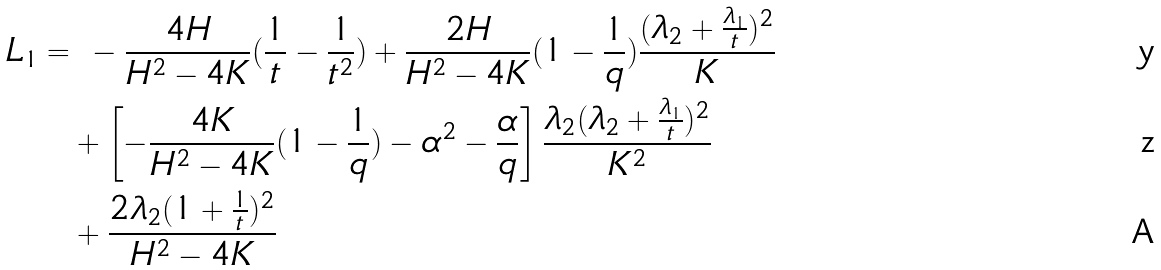<formula> <loc_0><loc_0><loc_500><loc_500>L _ { 1 } = & \ - \frac { 4 H } { H ^ { 2 } - 4 K } ( \frac { 1 } { t } - \frac { 1 } { t ^ { 2 } } ) + \frac { 2 H } { H ^ { 2 } - 4 K } ( 1 - \frac { 1 } { q } ) \frac { ( \lambda _ { 2 } + \frac { \lambda _ { 1 } } { t } ) ^ { 2 } } { K } \\ & + \left [ - \frac { 4 K } { H ^ { 2 } - 4 K } ( 1 - \frac { 1 } { q } ) - \alpha ^ { 2 } - \frac { \alpha } q \right ] \frac { \lambda _ { 2 } ( \lambda _ { 2 } + \frac { \lambda _ { 1 } } { t } ) ^ { 2 } } { K ^ { 2 } } \\ & + \frac { 2 \lambda _ { 2 } ( 1 + \frac { 1 } { t } ) ^ { 2 } } { H ^ { 2 } - 4 K }</formula> 